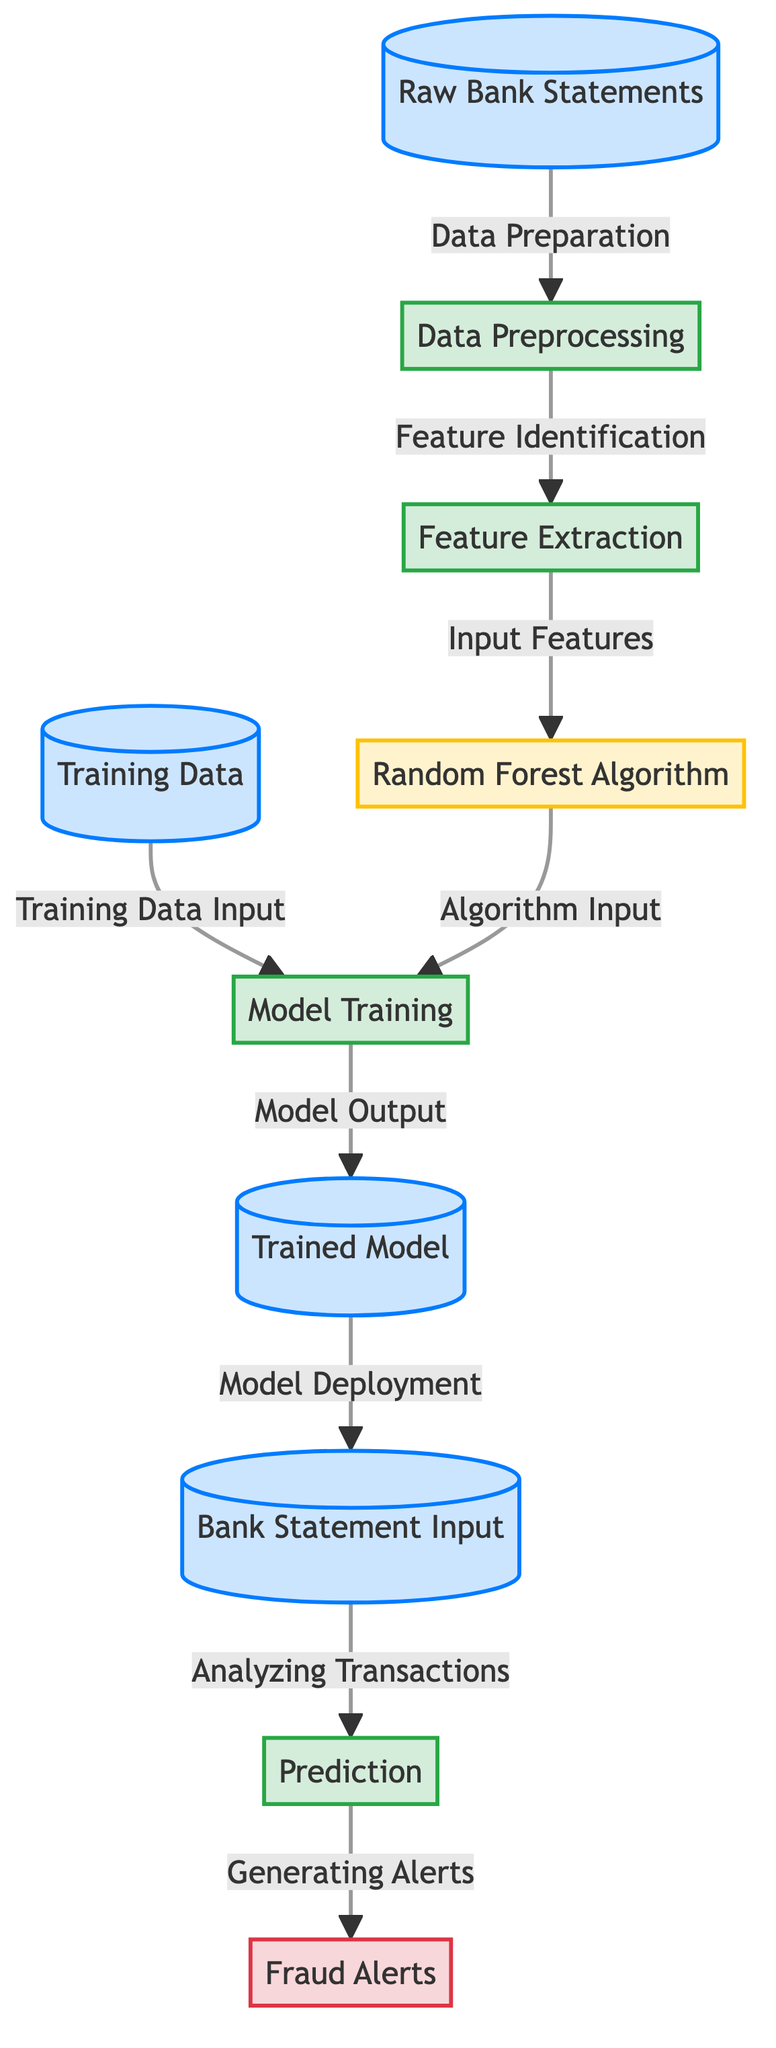What is the first step in the diagram? The first step is represented by the node titled "Raw Bank Statements," indicating the initial input data to be processed.
Answer: Raw Bank Statements How many processes are depicted in the diagram? The diagram shows four processes: "Data Preprocessing", "Feature Extraction", "Model Training", and "Prediction".
Answer: Four Which node generates the "Fraud Alerts"? The node labeled "Prediction" directly leads to the output node "Fraud Alerts", indicating it is responsible for generating alerts.
Answer: Prediction What is the input for the "Random Forest Algorithm"? The "Random Forest Algorithm" node receives input from the "Feature Extraction" node, as shown in the directed flow.
Answer: Input features What is the output of the "Model Training" step? The "Model Training" step outputs to the "Trained Model" node, which signifies the result of training the model.
Answer: Trained Model What is the relationship between "Training Data" and "Model Training"? "Training Data" serves as input for the "Model Training" process, illustrating that it is necessary for the training phase.
Answer: Input What step follows after the "Trained Model" is created? After the "Trained Model" is created, it goes through the step of "Model Deployment" which is depicted in the flow.
Answer: Model Deployment How does the model analyze transactions? The model analyzes transactions by receiving "Bank Statement Input", which feeds into the "Prediction" process for anomaly detection.
Answer: Bank Statement Input What does the "Feature Extraction" process focus on? The "Feature Extraction" process focuses on "Feature Identification", which highlights its role in selecting relevant features for the model's training.
Answer: Feature Identification 